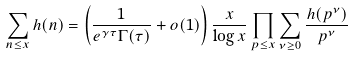Convert formula to latex. <formula><loc_0><loc_0><loc_500><loc_500>\sum _ { n \leq x } h ( n ) = \left ( \frac { 1 } { e ^ { \gamma \tau } \Gamma ( \tau ) } + o ( 1 ) \right ) \frac { x } { \log x } \prod _ { p \leq x } \sum _ { \nu \geq 0 } \frac { h ( p ^ { \nu } ) } { p ^ { \nu } }</formula> 